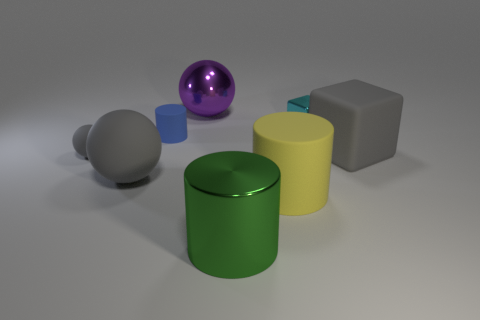Subtract all small rubber cylinders. How many cylinders are left? 2 Add 1 blue cylinders. How many objects exist? 9 Subtract all purple spheres. How many spheres are left? 2 Subtract all cylinders. How many objects are left? 5 Subtract 2 cubes. How many cubes are left? 0 Subtract all cyan cylinders. How many purple balls are left? 1 Subtract all tiny cyan blocks. Subtract all yellow objects. How many objects are left? 6 Add 1 big cylinders. How many big cylinders are left? 3 Add 5 cyan metallic spheres. How many cyan metallic spheres exist? 5 Subtract 0 purple cylinders. How many objects are left? 8 